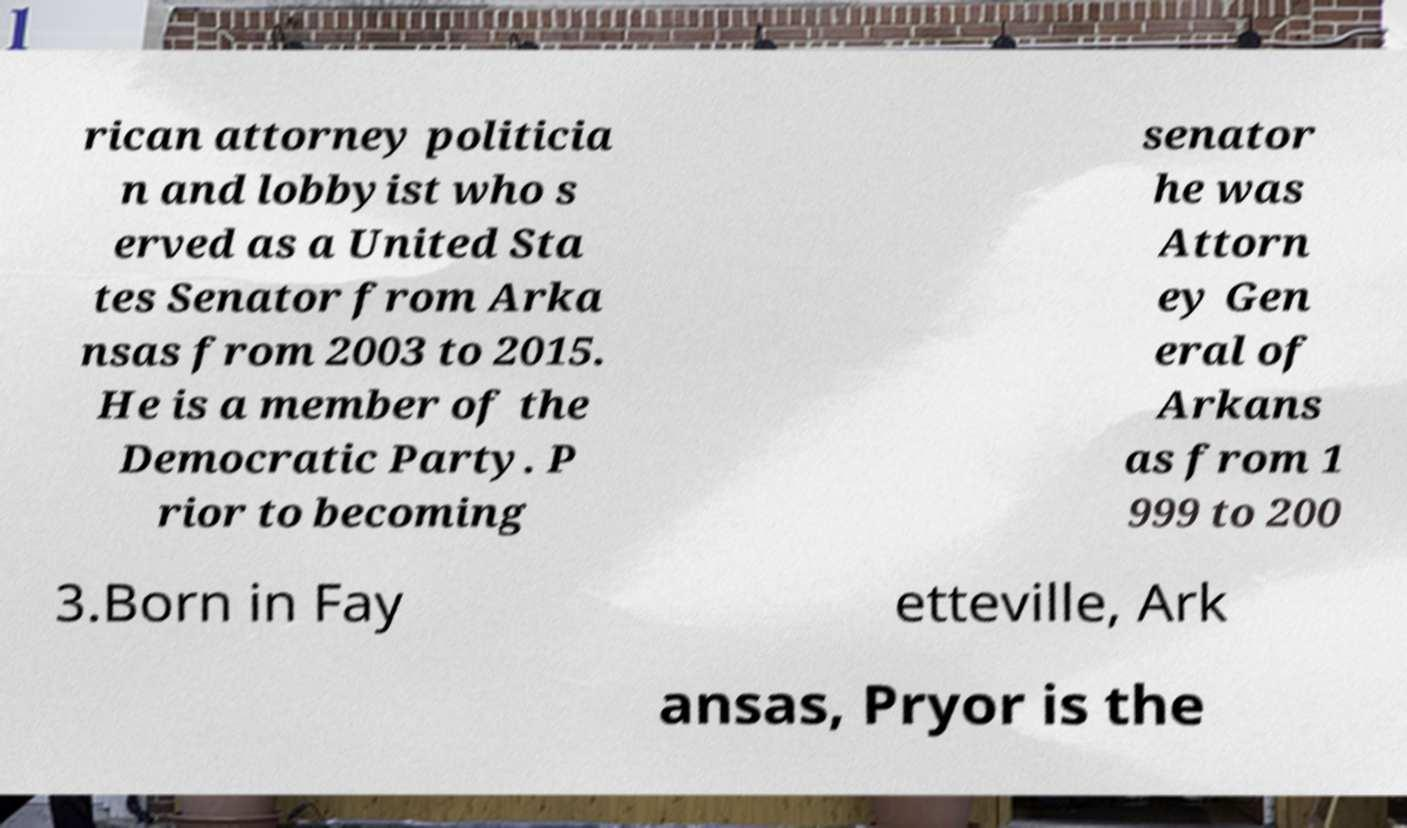I need the written content from this picture converted into text. Can you do that? rican attorney politicia n and lobbyist who s erved as a United Sta tes Senator from Arka nsas from 2003 to 2015. He is a member of the Democratic Party. P rior to becoming senator he was Attorn ey Gen eral of Arkans as from 1 999 to 200 3.Born in Fay etteville, Ark ansas, Pryor is the 